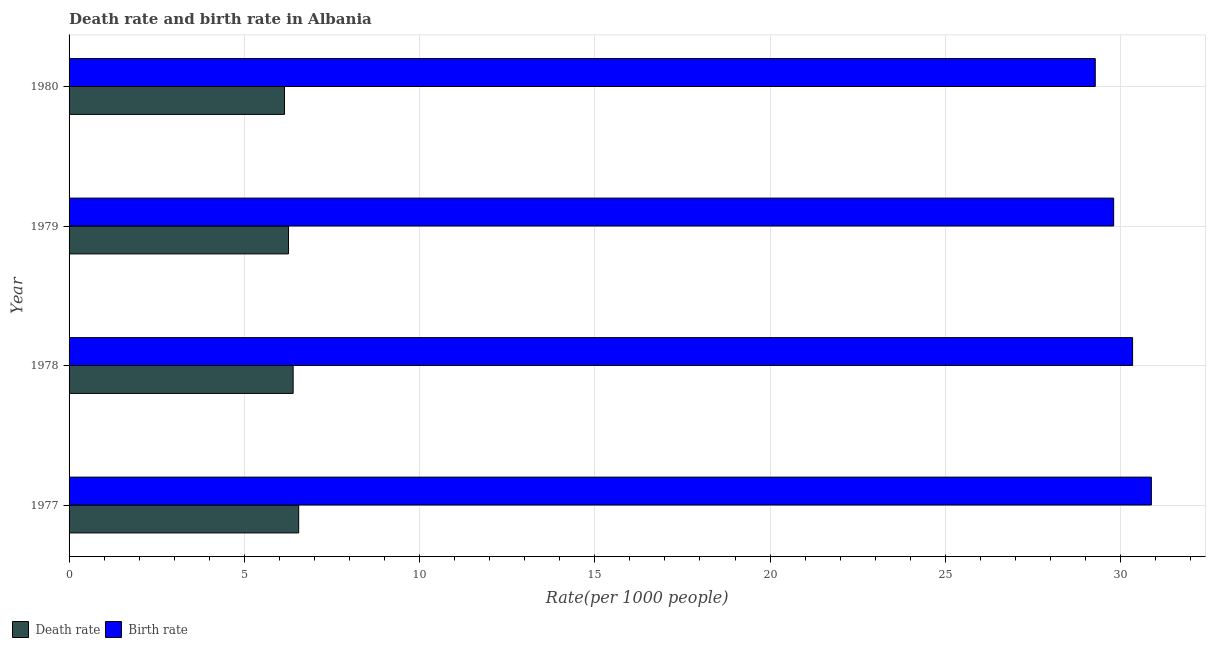How many bars are there on the 4th tick from the top?
Give a very brief answer. 2. How many bars are there on the 1st tick from the bottom?
Your response must be concise. 2. In how many cases, is the number of bars for a given year not equal to the number of legend labels?
Make the answer very short. 0. What is the birth rate in 1978?
Offer a very short reply. 30.34. Across all years, what is the maximum birth rate?
Offer a terse response. 30.88. Across all years, what is the minimum birth rate?
Provide a succinct answer. 29.28. What is the total birth rate in the graph?
Your answer should be very brief. 120.3. What is the difference between the birth rate in 1977 and that in 1979?
Offer a very short reply. 1.08. What is the difference between the death rate in 1977 and the birth rate in 1980?
Your response must be concise. -22.73. What is the average birth rate per year?
Give a very brief answer. 30.08. In the year 1978, what is the difference between the birth rate and death rate?
Offer a terse response. 23.95. What is the ratio of the birth rate in 1978 to that in 1980?
Provide a short and direct response. 1.04. Is the difference between the death rate in 1977 and 1980 greater than the difference between the birth rate in 1977 and 1980?
Your answer should be very brief. No. What is the difference between the highest and the second highest birth rate?
Give a very brief answer. 0.54. What is the difference between the highest and the lowest death rate?
Offer a terse response. 0.4. Is the sum of the death rate in 1977 and 1980 greater than the maximum birth rate across all years?
Provide a short and direct response. No. What does the 2nd bar from the top in 1980 represents?
Provide a short and direct response. Death rate. What does the 2nd bar from the bottom in 1979 represents?
Keep it short and to the point. Birth rate. Are all the bars in the graph horizontal?
Your answer should be compact. Yes. Are the values on the major ticks of X-axis written in scientific E-notation?
Provide a short and direct response. No. How are the legend labels stacked?
Your answer should be very brief. Horizontal. What is the title of the graph?
Offer a terse response. Death rate and birth rate in Albania. Does "Secondary school" appear as one of the legend labels in the graph?
Give a very brief answer. No. What is the label or title of the X-axis?
Offer a very short reply. Rate(per 1000 people). What is the Rate(per 1000 people) in Death rate in 1977?
Offer a very short reply. 6.55. What is the Rate(per 1000 people) in Birth rate in 1977?
Your response must be concise. 30.88. What is the Rate(per 1000 people) in Death rate in 1978?
Give a very brief answer. 6.39. What is the Rate(per 1000 people) in Birth rate in 1978?
Provide a short and direct response. 30.34. What is the Rate(per 1000 people) in Death rate in 1979?
Keep it short and to the point. 6.26. What is the Rate(per 1000 people) in Birth rate in 1979?
Provide a succinct answer. 29.8. What is the Rate(per 1000 people) of Death rate in 1980?
Ensure brevity in your answer.  6.15. What is the Rate(per 1000 people) of Birth rate in 1980?
Offer a terse response. 29.28. Across all years, what is the maximum Rate(per 1000 people) in Death rate?
Offer a terse response. 6.55. Across all years, what is the maximum Rate(per 1000 people) of Birth rate?
Ensure brevity in your answer.  30.88. Across all years, what is the minimum Rate(per 1000 people) in Death rate?
Give a very brief answer. 6.15. Across all years, what is the minimum Rate(per 1000 people) of Birth rate?
Offer a terse response. 29.28. What is the total Rate(per 1000 people) of Death rate in the graph?
Keep it short and to the point. 25.35. What is the total Rate(per 1000 people) of Birth rate in the graph?
Provide a succinct answer. 120.3. What is the difference between the Rate(per 1000 people) in Death rate in 1977 and that in 1978?
Give a very brief answer. 0.16. What is the difference between the Rate(per 1000 people) in Birth rate in 1977 and that in 1978?
Offer a very short reply. 0.54. What is the difference between the Rate(per 1000 people) of Death rate in 1977 and that in 1979?
Offer a terse response. 0.29. What is the difference between the Rate(per 1000 people) of Birth rate in 1977 and that in 1979?
Your response must be concise. 1.08. What is the difference between the Rate(per 1000 people) of Death rate in 1977 and that in 1980?
Give a very brief answer. 0.4. What is the difference between the Rate(per 1000 people) in Birth rate in 1977 and that in 1980?
Your response must be concise. 1.6. What is the difference between the Rate(per 1000 people) in Death rate in 1978 and that in 1979?
Your answer should be very brief. 0.13. What is the difference between the Rate(per 1000 people) of Birth rate in 1978 and that in 1979?
Ensure brevity in your answer.  0.54. What is the difference between the Rate(per 1000 people) in Death rate in 1978 and that in 1980?
Offer a very short reply. 0.25. What is the difference between the Rate(per 1000 people) of Birth rate in 1978 and that in 1980?
Offer a terse response. 1.06. What is the difference between the Rate(per 1000 people) in Death rate in 1979 and that in 1980?
Your response must be concise. 0.11. What is the difference between the Rate(per 1000 people) in Birth rate in 1979 and that in 1980?
Give a very brief answer. 0.53. What is the difference between the Rate(per 1000 people) of Death rate in 1977 and the Rate(per 1000 people) of Birth rate in 1978?
Provide a short and direct response. -23.79. What is the difference between the Rate(per 1000 people) of Death rate in 1977 and the Rate(per 1000 people) of Birth rate in 1979?
Ensure brevity in your answer.  -23.25. What is the difference between the Rate(per 1000 people) of Death rate in 1977 and the Rate(per 1000 people) of Birth rate in 1980?
Keep it short and to the point. -22.73. What is the difference between the Rate(per 1000 people) of Death rate in 1978 and the Rate(per 1000 people) of Birth rate in 1979?
Offer a terse response. -23.41. What is the difference between the Rate(per 1000 people) of Death rate in 1978 and the Rate(per 1000 people) of Birth rate in 1980?
Ensure brevity in your answer.  -22.89. What is the difference between the Rate(per 1000 people) of Death rate in 1979 and the Rate(per 1000 people) of Birth rate in 1980?
Ensure brevity in your answer.  -23.02. What is the average Rate(per 1000 people) of Death rate per year?
Your answer should be compact. 6.34. What is the average Rate(per 1000 people) in Birth rate per year?
Provide a short and direct response. 30.08. In the year 1977, what is the difference between the Rate(per 1000 people) of Death rate and Rate(per 1000 people) of Birth rate?
Provide a succinct answer. -24.33. In the year 1978, what is the difference between the Rate(per 1000 people) of Death rate and Rate(per 1000 people) of Birth rate?
Keep it short and to the point. -23.95. In the year 1979, what is the difference between the Rate(per 1000 people) of Death rate and Rate(per 1000 people) of Birth rate?
Ensure brevity in your answer.  -23.54. In the year 1980, what is the difference between the Rate(per 1000 people) in Death rate and Rate(per 1000 people) in Birth rate?
Provide a succinct answer. -23.13. What is the ratio of the Rate(per 1000 people) of Death rate in 1977 to that in 1978?
Offer a very short reply. 1.02. What is the ratio of the Rate(per 1000 people) of Birth rate in 1977 to that in 1978?
Give a very brief answer. 1.02. What is the ratio of the Rate(per 1000 people) in Death rate in 1977 to that in 1979?
Give a very brief answer. 1.05. What is the ratio of the Rate(per 1000 people) in Birth rate in 1977 to that in 1979?
Give a very brief answer. 1.04. What is the ratio of the Rate(per 1000 people) in Death rate in 1977 to that in 1980?
Your answer should be compact. 1.07. What is the ratio of the Rate(per 1000 people) of Birth rate in 1977 to that in 1980?
Your answer should be compact. 1.05. What is the ratio of the Rate(per 1000 people) of Death rate in 1978 to that in 1979?
Provide a short and direct response. 1.02. What is the ratio of the Rate(per 1000 people) of Birth rate in 1978 to that in 1979?
Your answer should be compact. 1.02. What is the ratio of the Rate(per 1000 people) of Birth rate in 1978 to that in 1980?
Your response must be concise. 1.04. What is the ratio of the Rate(per 1000 people) in Death rate in 1979 to that in 1980?
Keep it short and to the point. 1.02. What is the ratio of the Rate(per 1000 people) in Birth rate in 1979 to that in 1980?
Your answer should be very brief. 1.02. What is the difference between the highest and the second highest Rate(per 1000 people) in Death rate?
Offer a terse response. 0.16. What is the difference between the highest and the second highest Rate(per 1000 people) of Birth rate?
Provide a short and direct response. 0.54. What is the difference between the highest and the lowest Rate(per 1000 people) in Death rate?
Ensure brevity in your answer.  0.4. What is the difference between the highest and the lowest Rate(per 1000 people) of Birth rate?
Offer a very short reply. 1.6. 